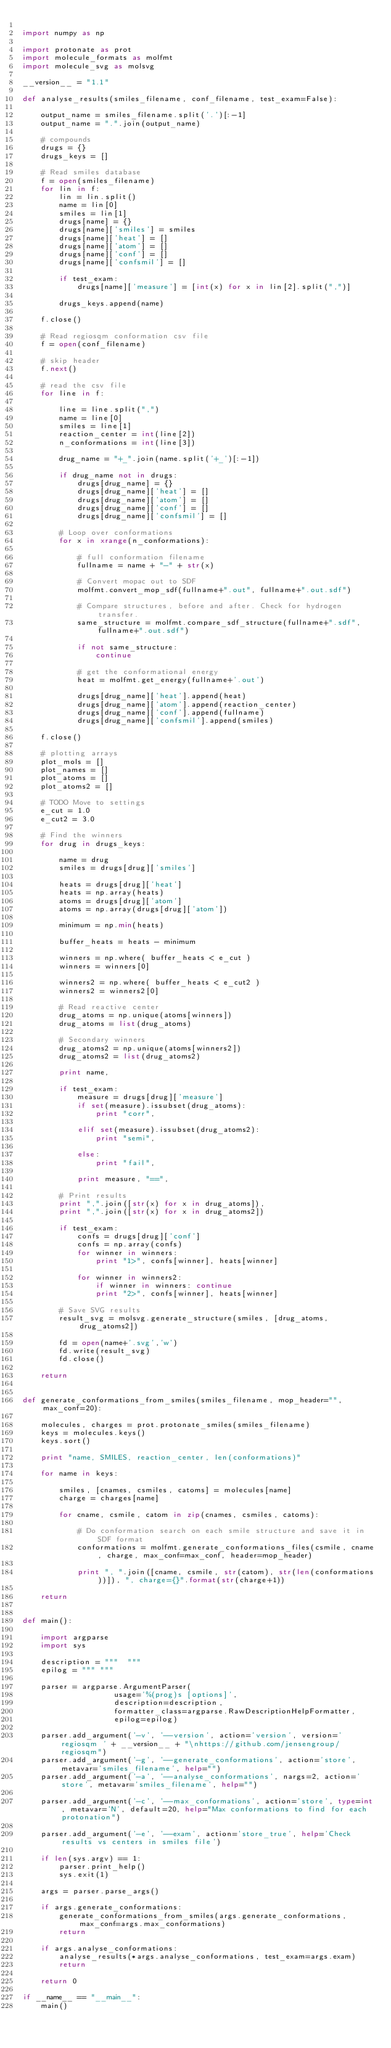Convert code to text. <code><loc_0><loc_0><loc_500><loc_500><_Python_>
import numpy as np

import protonate as prot
import molecule_formats as molfmt
import molecule_svg as molsvg

__version__ = "1.1"

def analyse_results(smiles_filename, conf_filename, test_exam=False):

    output_name = smiles_filename.split('.')[:-1]
    output_name = ".".join(output_name)

    # compounds
    drugs = {}
    drugs_keys = []

    # Read smiles database
    f = open(smiles_filename)
    for lin in f:
        lin = lin.split()
        name = lin[0]
        smiles = lin[1]
        drugs[name] = {}
        drugs[name]['smiles'] = smiles
        drugs[name]['heat'] = []
        drugs[name]['atom'] = []
        drugs[name]['conf'] = []
        drugs[name]['confsmil'] = []

        if test_exam:
            drugs[name]['measure'] = [int(x) for x in lin[2].split(",")]

        drugs_keys.append(name)

    f.close()

    # Read regiosqm conformation csv file
    f = open(conf_filename)

    # skip header
    f.next()

    # read the csv file
    for line in f:

        line = line.split(",")
        name = line[0]
        smiles = line[1]
        reaction_center = int(line[2])
        n_conformations = int(line[3])

        drug_name = "+_".join(name.split('+_')[:-1])

        if drug_name not in drugs:
            drugs[drug_name] = {}
            drugs[drug_name]['heat'] = []
            drugs[drug_name]['atom'] = []
            drugs[drug_name]['conf'] = []
            drugs[drug_name]['confsmil'] = []

        # Loop over conformations
        for x in xrange(n_conformations):

            # full conformation filename
            fullname = name + "-" + str(x)

            # Convert mopac out to SDF
            molfmt.convert_mop_sdf(fullname+".out", fullname+".out.sdf")

            # Compare structures, before and after. Check for hydrogen transfer.
            same_structure = molfmt.compare_sdf_structure(fullname+".sdf", fullname+".out.sdf")

            if not same_structure:
                continue

            # get the conformational energy
            heat = molfmt.get_energy(fullname+'.out')

            drugs[drug_name]['heat'].append(heat)
            drugs[drug_name]['atom'].append(reaction_center)
            drugs[drug_name]['conf'].append(fullname)
            drugs[drug_name]['confsmil'].append(smiles)

    f.close()

    # plotting arrays
    plot_mols = []
    plot_names = []
    plot_atoms = []
    plot_atoms2 = []

    # TODO Move to settings
    e_cut = 1.0
    e_cut2 = 3.0

    # Find the winners
    for drug in drugs_keys:

        name = drug
        smiles = drugs[drug]['smiles']

        heats = drugs[drug]['heat']
        heats = np.array(heats)
        atoms = drugs[drug]['atom']
        atoms = np.array(drugs[drug]['atom'])

        minimum = np.min(heats)

        buffer_heats = heats - minimum

        winners = np.where( buffer_heats < e_cut )
        winners = winners[0]

        winners2 = np.where( buffer_heats < e_cut2 )
        winners2 = winners2[0]

        # Read reactive center
        drug_atoms = np.unique(atoms[winners])
        drug_atoms = list(drug_atoms)

        # Secondary winners
        drug_atoms2 = np.unique(atoms[winners2])
        drug_atoms2 = list(drug_atoms2)

        print name,

        if test_exam:
            measure = drugs[drug]['measure']
            if set(measure).issubset(drug_atoms):
                print "corr",

            elif set(measure).issubset(drug_atoms2):
                print "semi",

            else:
                print "fail",

            print measure, "==",

        # Print results
        print ",".join([str(x) for x in drug_atoms]),
        print ",".join([str(x) for x in drug_atoms2])

        if test_exam:
            confs = drugs[drug]['conf']
            confs = np.array(confs)
            for winner in winners:
                print "1>", confs[winner], heats[winner]

            for winner in winners2:
                if winner in winners: continue
                print "2>", confs[winner], heats[winner]

        # Save SVG results
        result_svg = molsvg.generate_structure(smiles, [drug_atoms, drug_atoms2])

        fd = open(name+'.svg','w')
        fd.write(result_svg)
        fd.close()

    return


def generate_conformations_from_smiles(smiles_filename, mop_header="", max_conf=20):

    molecules, charges = prot.protonate_smiles(smiles_filename)
    keys = molecules.keys()
    keys.sort()

    print "name, SMILES, reaction_center, len(conformations)"

    for name in keys:

        smiles, [cnames, csmiles, catoms] = molecules[name]
        charge = charges[name]

        for cname, csmile, catom in zip(cnames, csmiles, catoms):

            # Do conformation search on each smile structure and save it in SDF format
            conformations = molfmt.generate_conformations_files(csmile, cname, charge, max_conf=max_conf, header=mop_header)

            print ", ".join([cname, csmile, str(catom), str(len(conformations))]), ", charge={}".format(str(charge+1))

    return


def main():

    import argparse
    import sys

    description = """  """
    epilog = """ """

    parser = argparse.ArgumentParser(
                    usage='%(prog)s [options]',
                    description=description,
                    formatter_class=argparse.RawDescriptionHelpFormatter,
                    epilog=epilog)

    parser.add_argument('-v', '--version', action='version', version='regiosqm ' + __version__ + "\nhttps://github.com/jensengroup/regiosqm")
    parser.add_argument('-g', '--generate_conformations', action='store', metavar='smiles_filename', help="")
    parser.add_argument('-a', '--analyse_conformations', nargs=2, action='store', metavar='smiles_filename', help="")

    parser.add_argument('-c', '--max_conformations', action='store', type=int, metavar='N', default=20, help="Max conformations to find for each protonation")

    parser.add_argument('-e', '--exam', action='store_true', help='Check results vs centers in smiles file')

    if len(sys.argv) == 1:
        parser.print_help()
        sys.exit(1)

    args = parser.parse_args()

    if args.generate_conformations:
        generate_conformations_from_smiles(args.generate_conformations, max_conf=args.max_conformations)
        return

    if args.analyse_conformations:
        analyse_results(*args.analyse_conformations, test_exam=args.exam)
        return

    return 0

if __name__ == "__main__":
    main()

</code> 